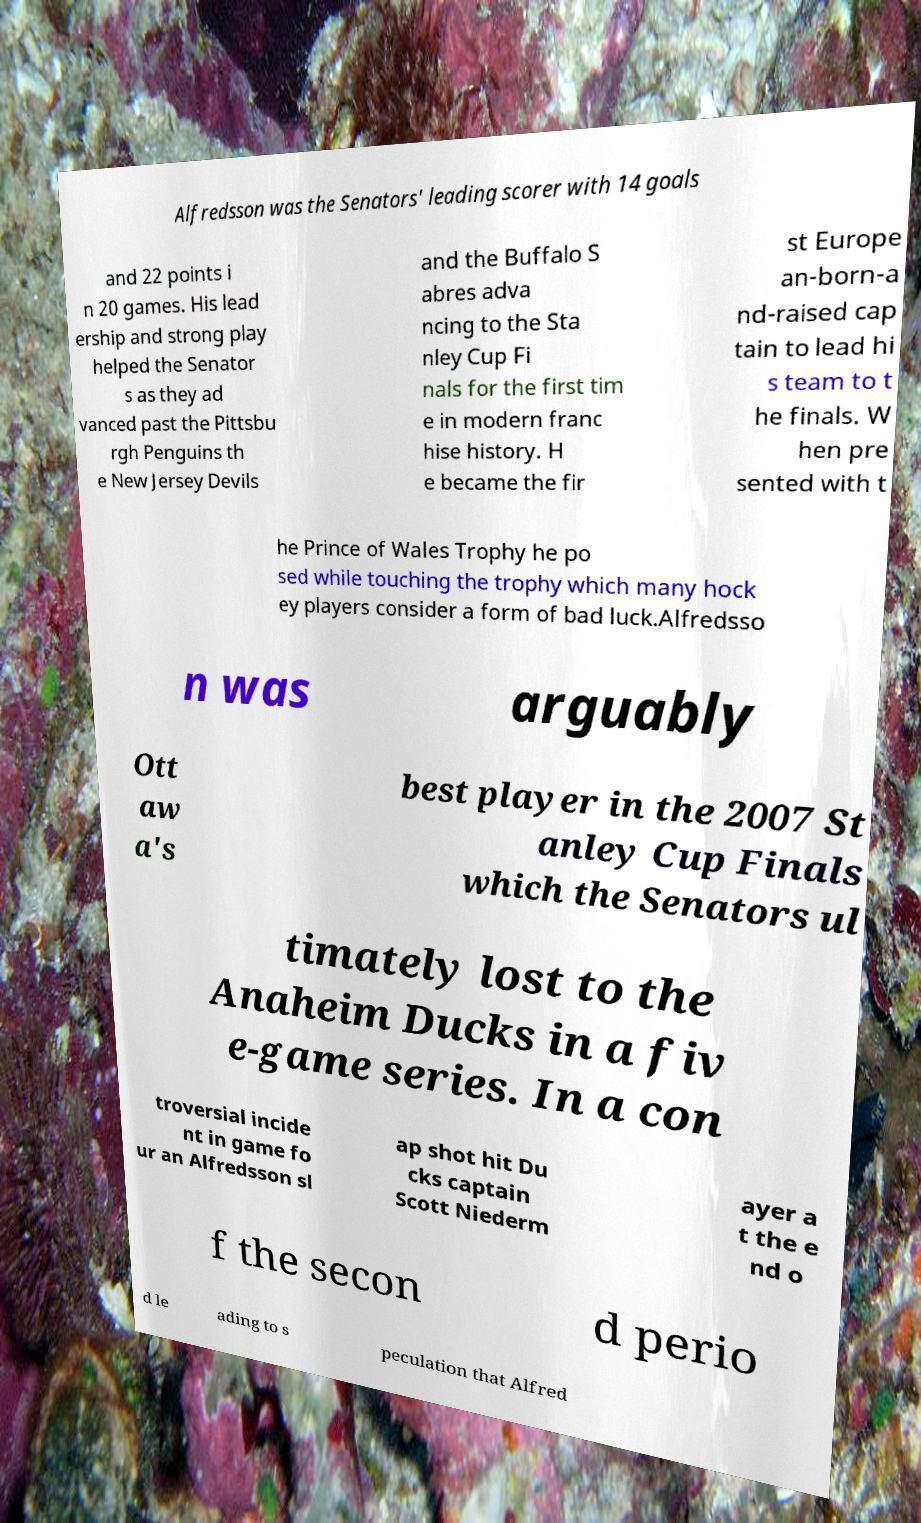Please identify and transcribe the text found in this image. Alfredsson was the Senators' leading scorer with 14 goals and 22 points i n 20 games. His lead ership and strong play helped the Senator s as they ad vanced past the Pittsbu rgh Penguins th e New Jersey Devils and the Buffalo S abres adva ncing to the Sta nley Cup Fi nals for the first tim e in modern franc hise history. H e became the fir st Europe an-born-a nd-raised cap tain to lead hi s team to t he finals. W hen pre sented with t he Prince of Wales Trophy he po sed while touching the trophy which many hock ey players consider a form of bad luck.Alfredsso n was arguably Ott aw a's best player in the 2007 St anley Cup Finals which the Senators ul timately lost to the Anaheim Ducks in a fiv e-game series. In a con troversial incide nt in game fo ur an Alfredsson sl ap shot hit Du cks captain Scott Niederm ayer a t the e nd o f the secon d perio d le ading to s peculation that Alfred 